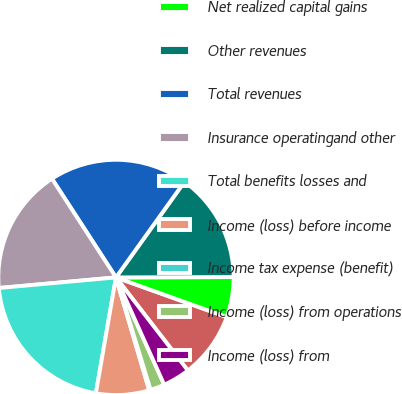Convert chart. <chart><loc_0><loc_0><loc_500><loc_500><pie_chart><fcel>Net investment income<fcel>Net realized capital gains<fcel>Other revenues<fcel>Total revenues<fcel>Insurance operatingand other<fcel>Total benefits losses and<fcel>Income (loss) before income<fcel>Income tax expense (benefit)<fcel>Income (loss) from operations<fcel>Income (loss) from<nl><fcel>9.06%<fcel>5.52%<fcel>15.06%<fcel>19.05%<fcel>17.28%<fcel>20.83%<fcel>7.29%<fcel>0.2%<fcel>1.97%<fcel>3.74%<nl></chart> 